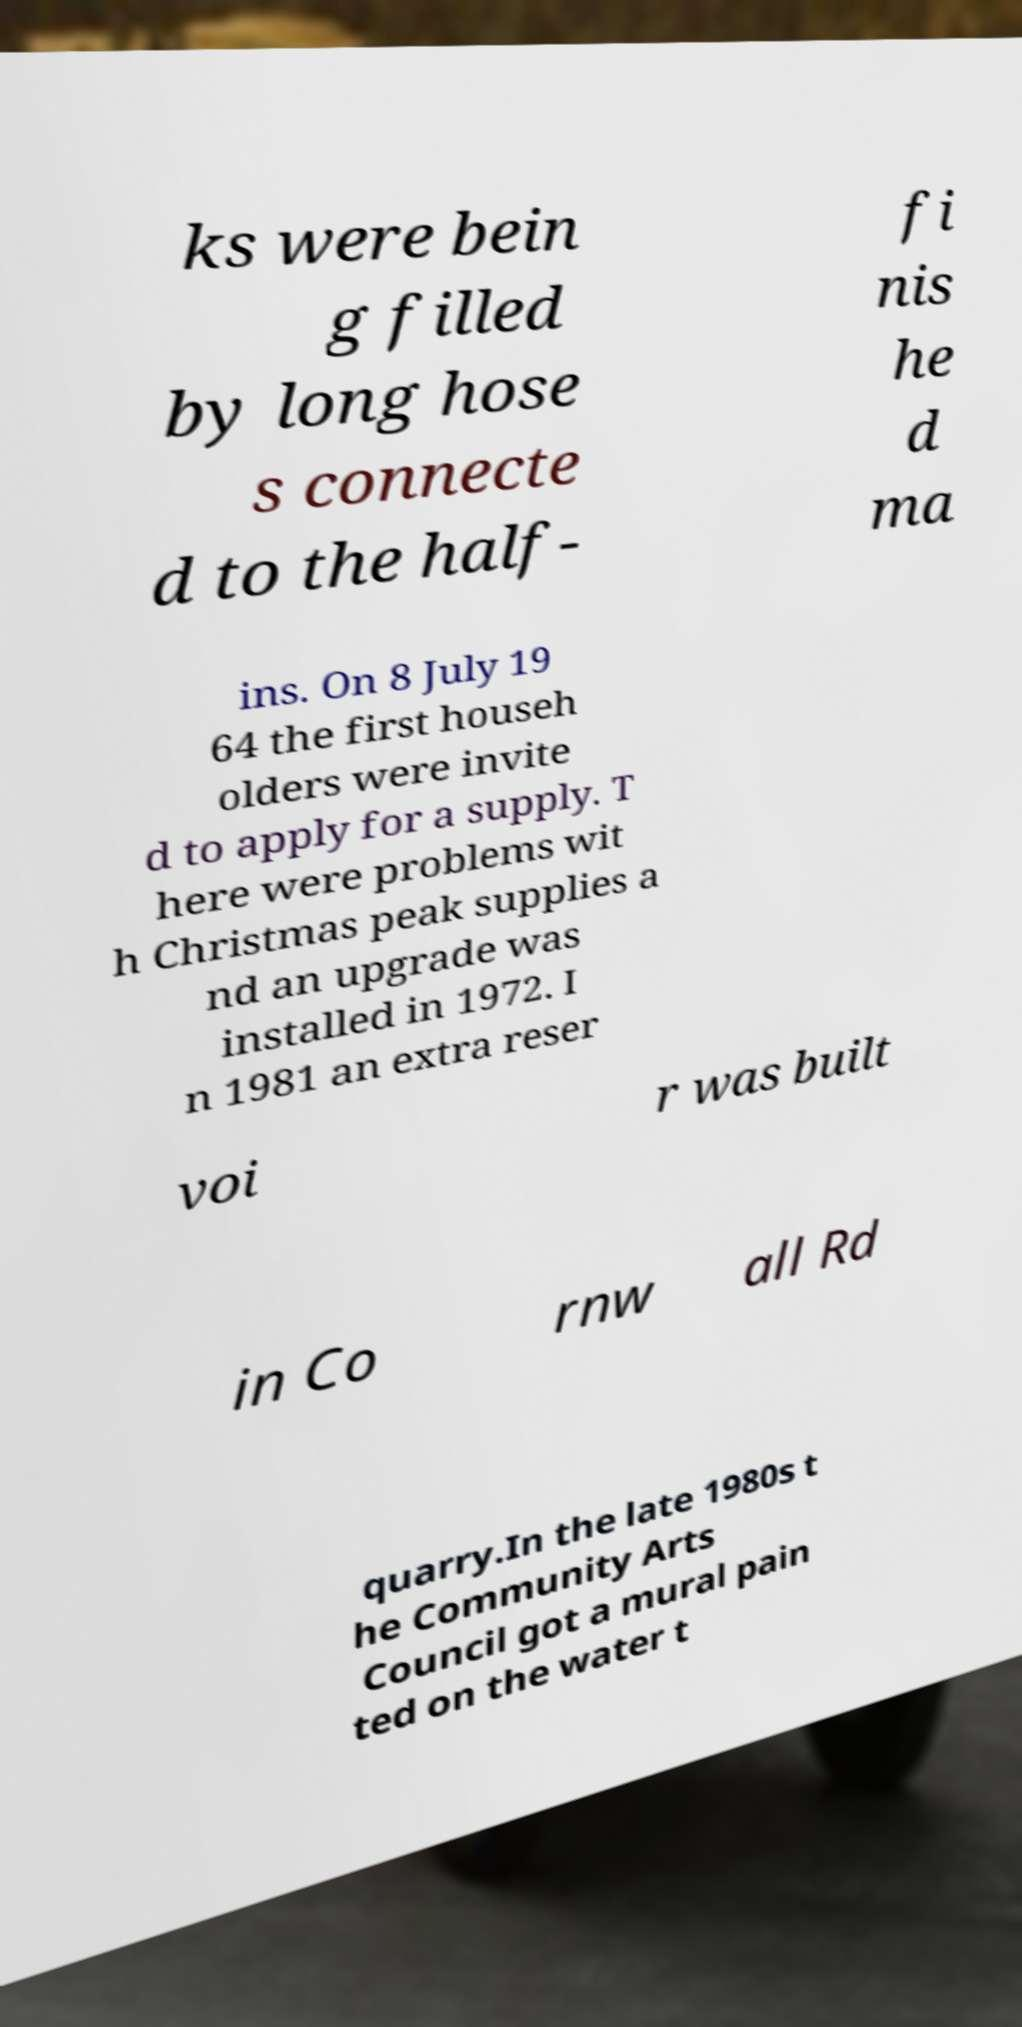There's text embedded in this image that I need extracted. Can you transcribe it verbatim? ks were bein g filled by long hose s connecte d to the half- fi nis he d ma ins. On 8 July 19 64 the first househ olders were invite d to apply for a supply. T here were problems wit h Christmas peak supplies a nd an upgrade was installed in 1972. I n 1981 an extra reser voi r was built in Co rnw all Rd quarry.In the late 1980s t he Community Arts Council got a mural pain ted on the water t 